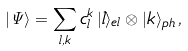Convert formula to latex. <formula><loc_0><loc_0><loc_500><loc_500>| { \mathit \Psi } \rangle = \sum _ { l , k } c _ { l } ^ { k } \, | l \rangle _ { e l } \otimes | k \rangle _ { p h } \, ,</formula> 